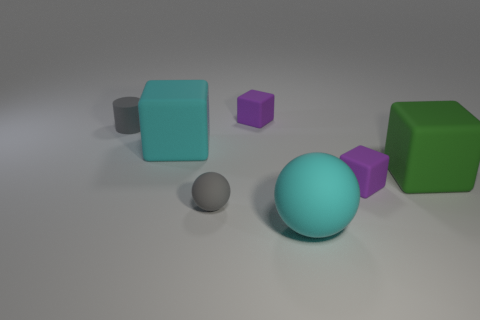Add 2 small gray cylinders. How many objects exist? 9 Subtract all cylinders. How many objects are left? 6 Add 1 cyan rubber things. How many cyan rubber things exist? 3 Subtract 2 purple cubes. How many objects are left? 5 Subtract all large brown balls. Subtract all gray cylinders. How many objects are left? 6 Add 4 tiny cylinders. How many tiny cylinders are left? 5 